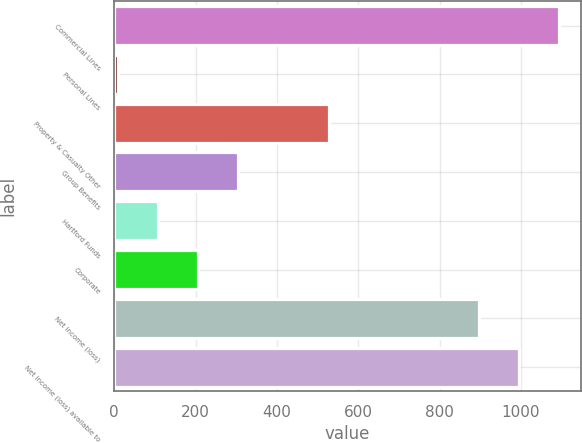Convert chart. <chart><loc_0><loc_0><loc_500><loc_500><bar_chart><fcel>Commercial Lines<fcel>Personal Lines<fcel>Property & Casualty Other<fcel>Group Benefits<fcel>Hartford Funds<fcel>Corporate<fcel>Net income (loss)<fcel>Net income (loss) available to<nl><fcel>1093<fcel>9<fcel>529<fcel>304.5<fcel>107.5<fcel>206<fcel>896<fcel>994.5<nl></chart> 